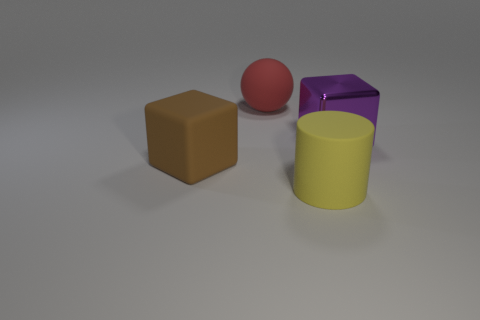Add 4 brown rubber cylinders. How many objects exist? 8 Subtract all cylinders. How many objects are left? 3 Add 3 small cyan rubber cubes. How many small cyan rubber cubes exist? 3 Subtract 0 red cubes. How many objects are left? 4 Subtract all small purple metallic cylinders. Subtract all yellow matte cylinders. How many objects are left? 3 Add 4 large red balls. How many large red balls are left? 5 